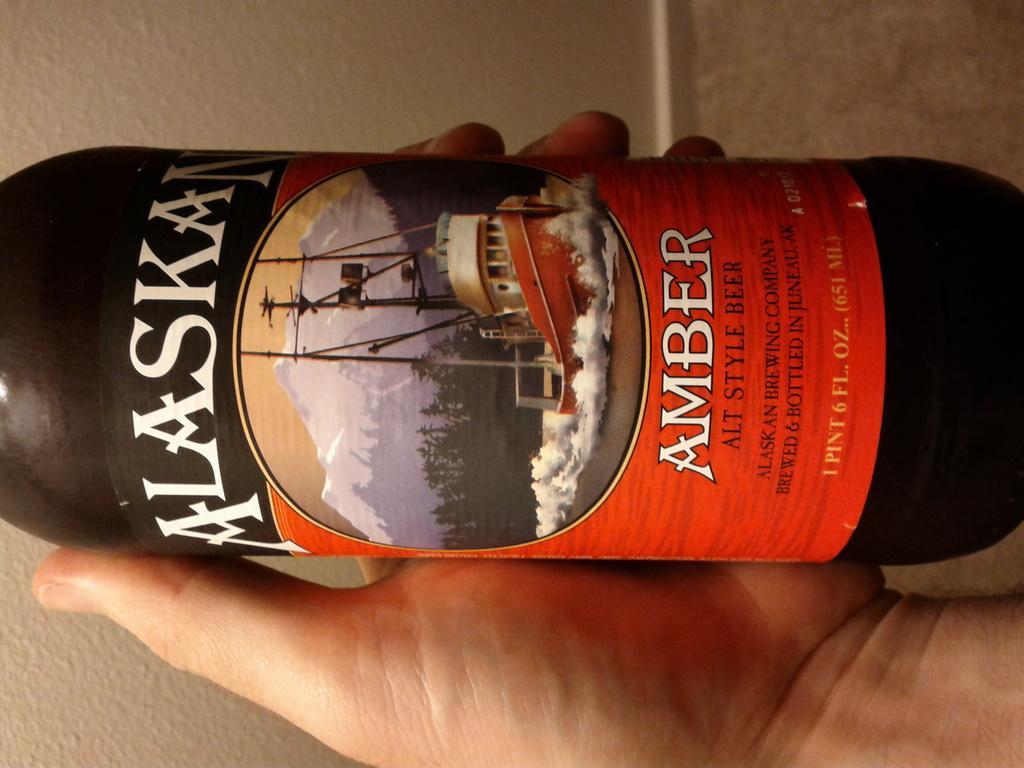Describe this image in one or two sentences. In this image we can see a bottle in the hand of a person. 